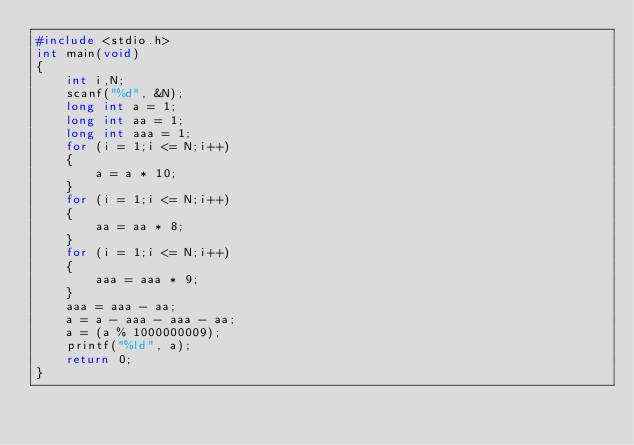<code> <loc_0><loc_0><loc_500><loc_500><_C_>#include <stdio.h>
int main(void)
{
    int i,N;
    scanf("%d", &N);
    long int a = 1;
    long int aa = 1;
    long int aaa = 1;
    for (i = 1;i <= N;i++)
    {
        a = a * 10;
    }
    for (i = 1;i <= N;i++)
    {
        aa = aa * 8;
    }
    for (i = 1;i <= N;i++)
    {
        aaa = aaa * 9;
    }
    aaa = aaa - aa;
    a = a - aaa - aaa - aa;
    a = (a % 1000000009);
    printf("%ld", a);
    return 0;
}</code> 